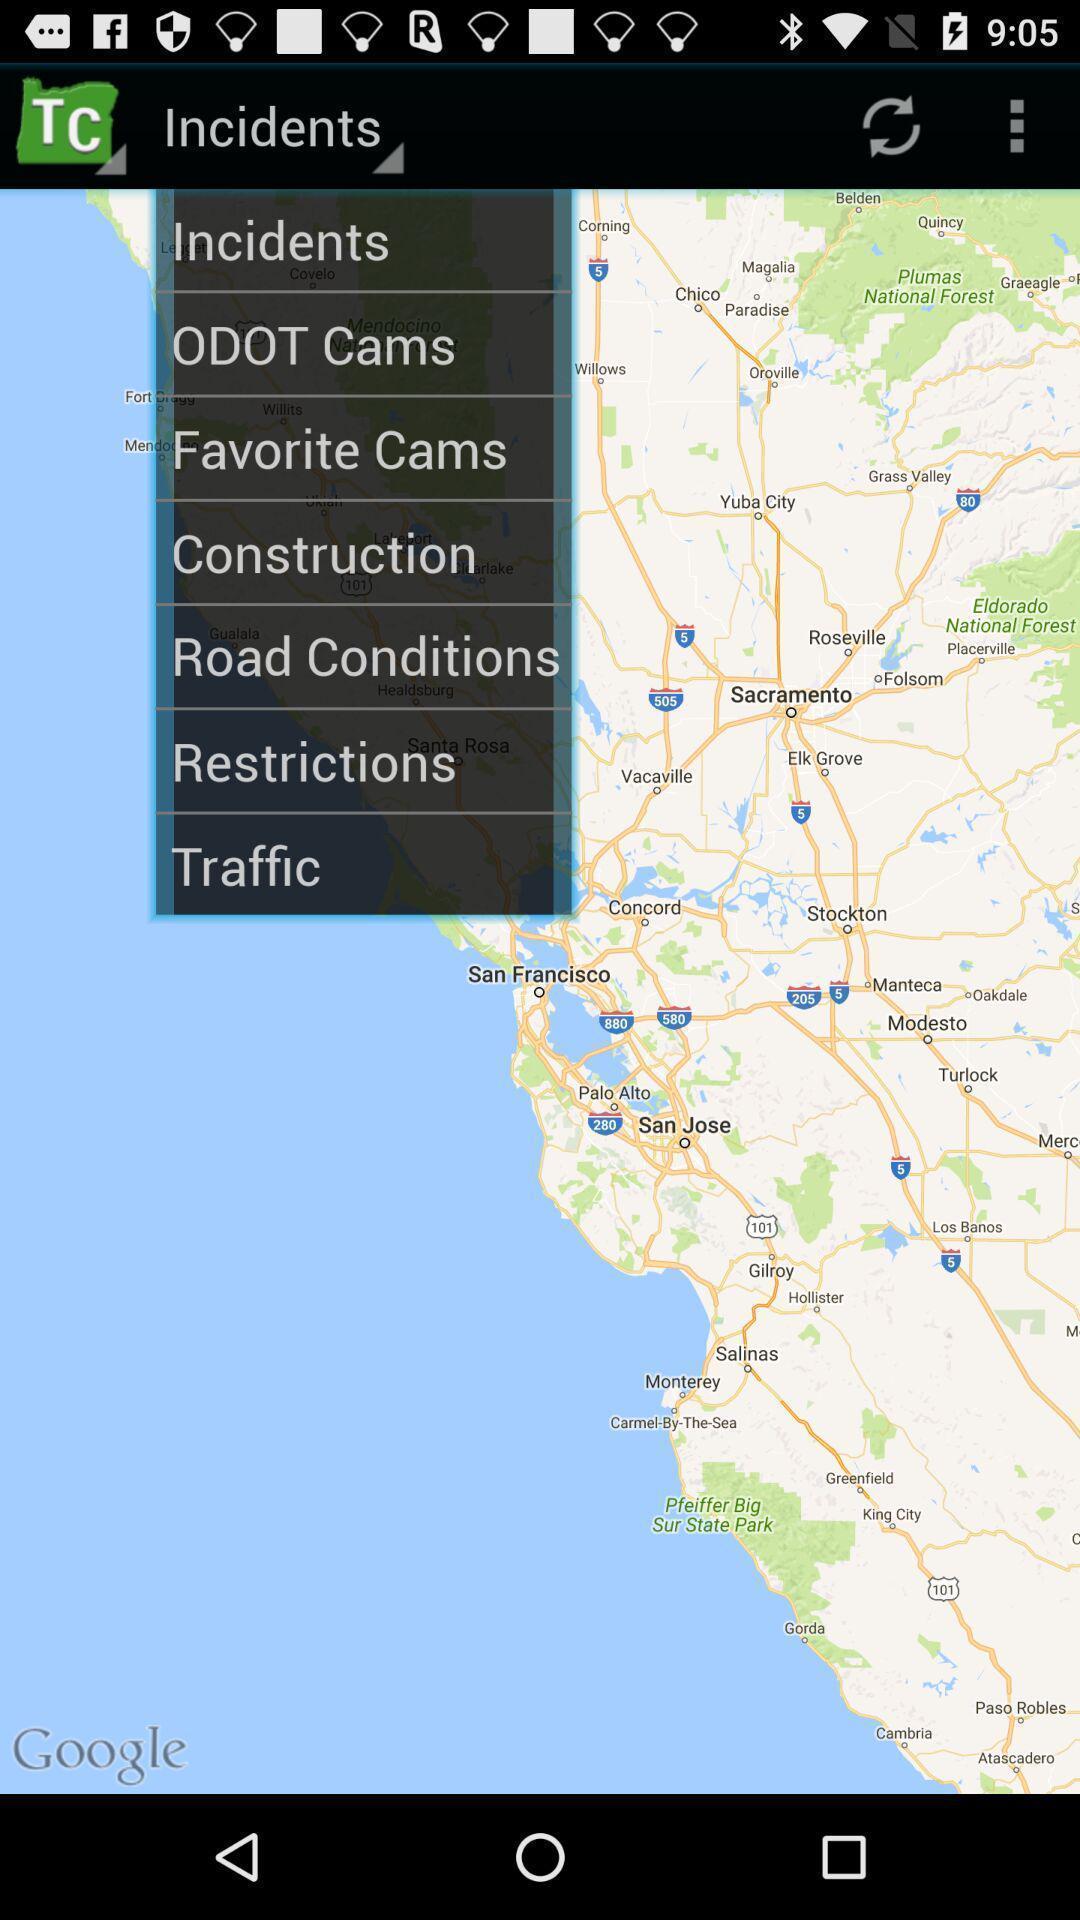Give me a narrative description of this picture. Pop up displaying different options in map application. 